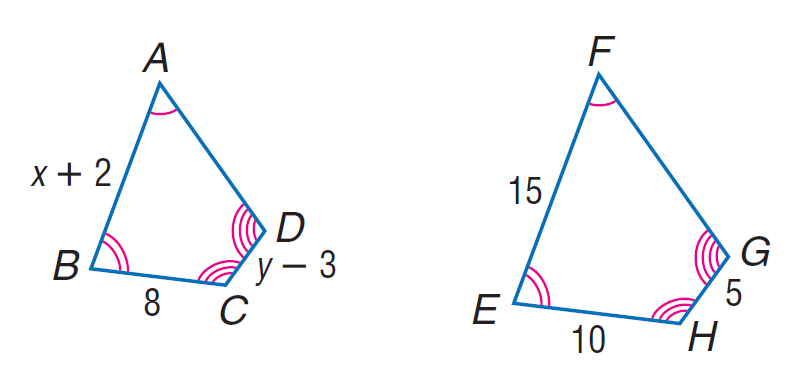Answer the mathemtical geometry problem and directly provide the correct option letter.
Question: Each pair of polygons is similar. Find x.
Choices: A: 5 B: 8 C: 10 D: 15 C 